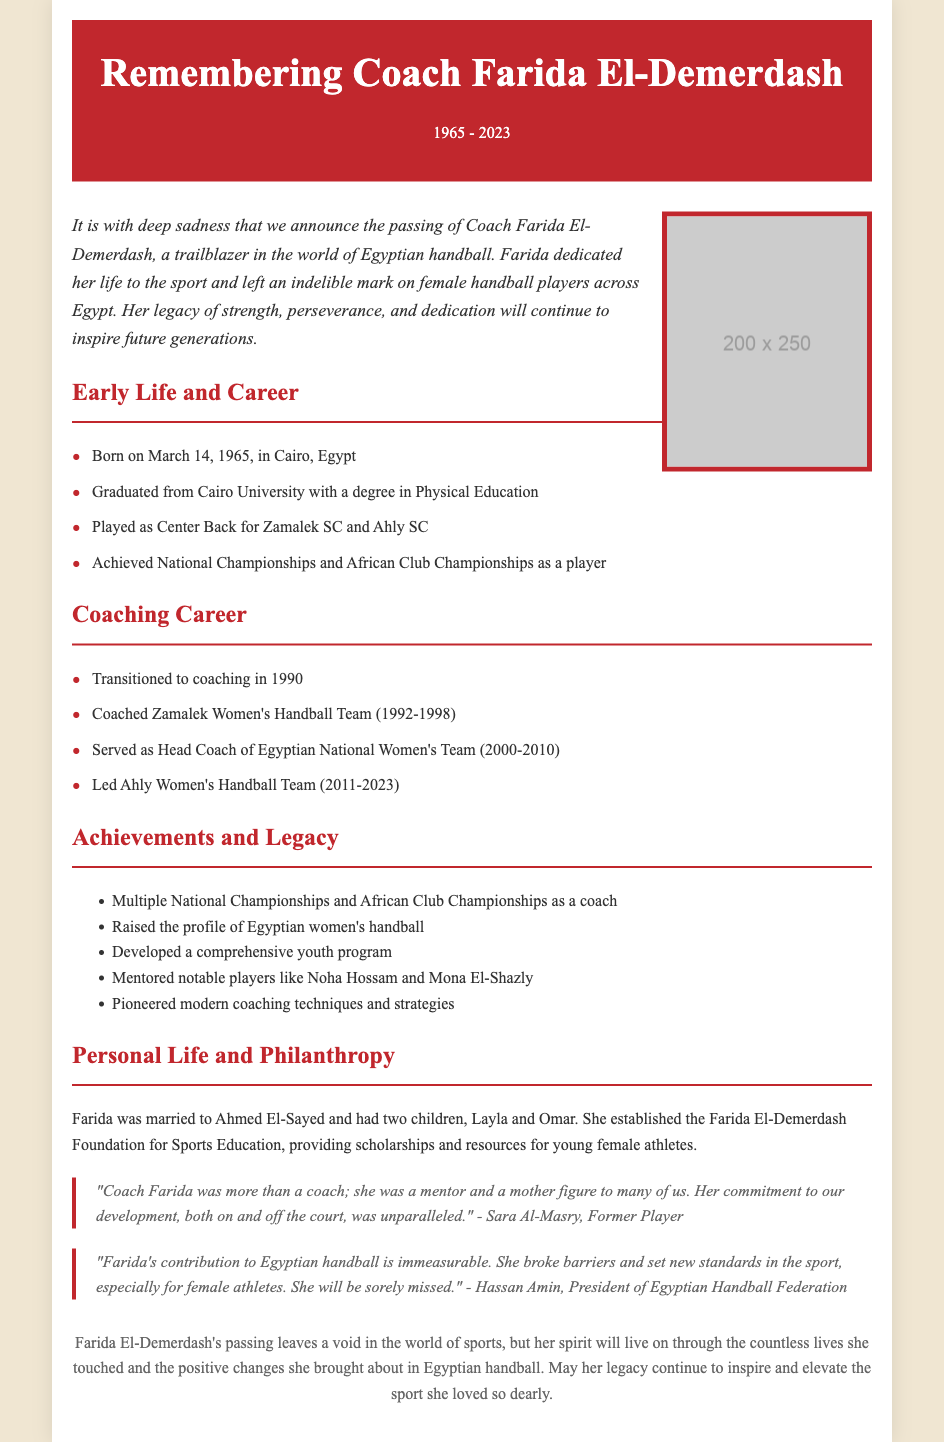what is the full name of the coach? The full name of the coach is mentioned at the beginning of the document.
Answer: Coach Farida El-Demerdash when was Coach Farida born? The document states her birth date directly in the early life section.
Answer: March 14, 1965 which teams did Coach Farida play for? The document lists the teams for which she played in her career.
Answer: Zamalek SC and Ahly SC what years did she coach the Egyptian National Women's Team? The timeline section provides the years she served as head coach.
Answer: 2000-2010 who were two notable players she mentored? The achievements section specifically mentions players she mentored.
Answer: Noha Hossam and Mona El-Shazly what foundation did Coach Farida establish? The document mentions the name of the foundation she created in her personal life section.
Answer: Farida El-Demerdash Foundation for Sports Education what is the significance of her contribution to Egyptian handball? The quotes emphasize her impact on the sport and its athletes.
Answer: She raised the profile of Egyptian women's handball how long did she coach the Ahly Women's Handball Team? The coaching career timeline specifies the duration she coached this team.
Answer: 2011-2023 who is quoted commenting on Coach Farida's contribution? The document includes quotes from individuals discussing her impact.
Answer: Hassan Amin, President of Egyptian Handball Federation 